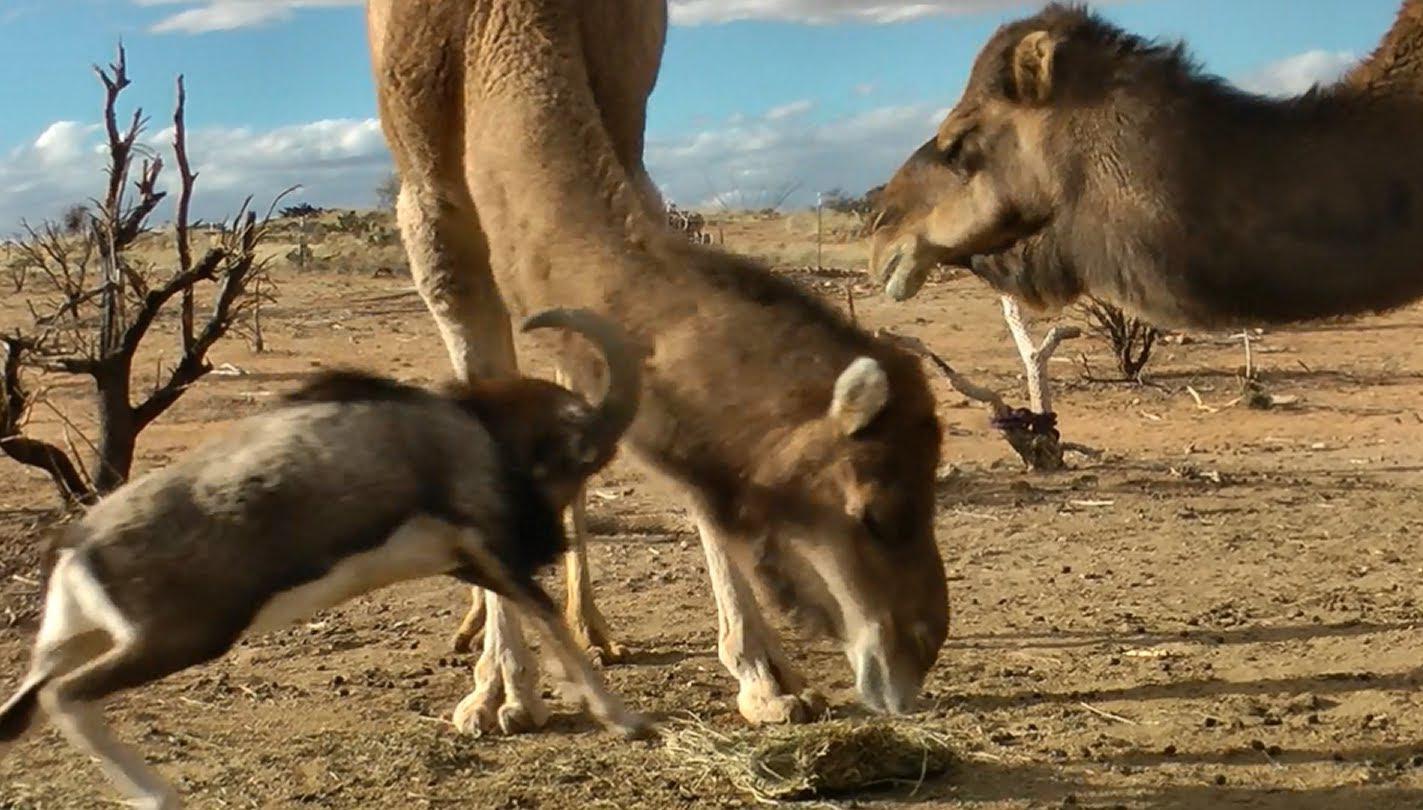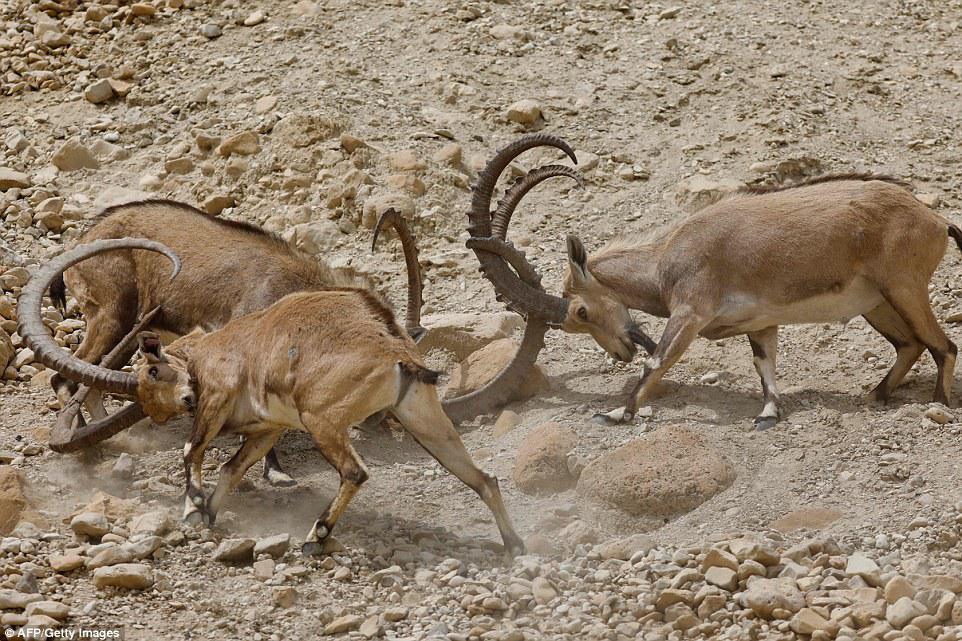The first image is the image on the left, the second image is the image on the right. For the images displayed, is the sentence "The left and right image contains the total  of five rams." factually correct? Answer yes or no. No. The first image is the image on the left, the second image is the image on the right. Analyze the images presented: Is the assertion "There is exactly two mountain goats in the right image." valid? Answer yes or no. No. 